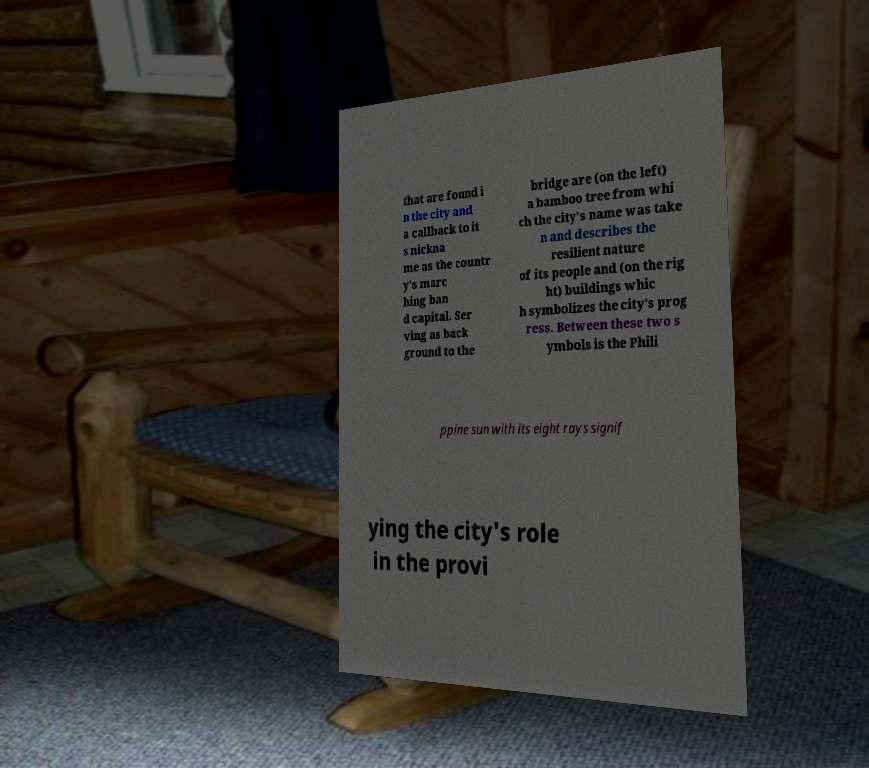For documentation purposes, I need the text within this image transcribed. Could you provide that? that are found i n the city and a callback to it s nickna me as the countr y's marc hing ban d capital. Ser ving as back ground to the bridge are (on the left) a bamboo tree from whi ch the city's name was take n and describes the resilient nature of its people and (on the rig ht) buildings whic h symbolizes the city's prog ress. Between these two s ymbols is the Phili ppine sun with its eight rays signif ying the city's role in the provi 